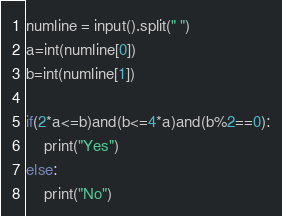<code> <loc_0><loc_0><loc_500><loc_500><_Python_>numline = input().split(" ")
a=int(numline[0])
b=int(numline[1])

if(2*a<=b)and(b<=4*a)and(b%2==0):
    print("Yes")
else:
    print("No")</code> 